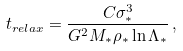<formula> <loc_0><loc_0><loc_500><loc_500>t _ { r e l a x } = \frac { C \sigma _ { * } ^ { 3 } } { G ^ { 2 } M _ { * } \rho _ { * } \ln \Lambda _ { * } } \, ,</formula> 